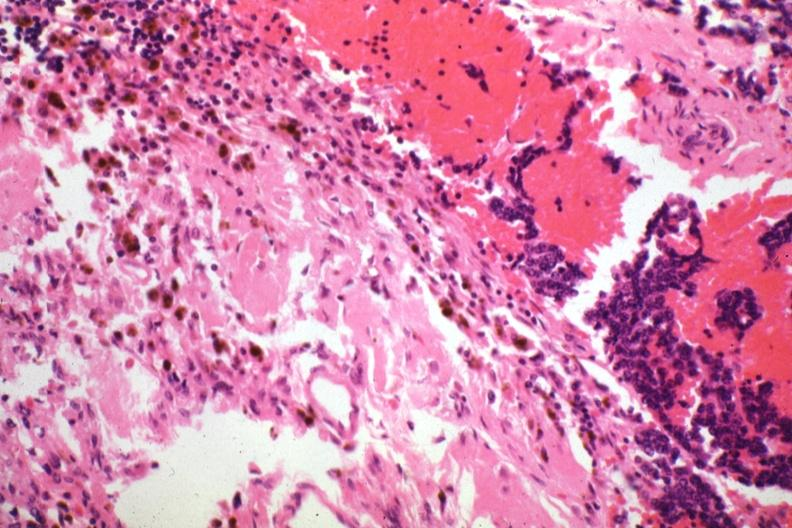what is present?
Answer the question using a single word or phrase. Endocrine 